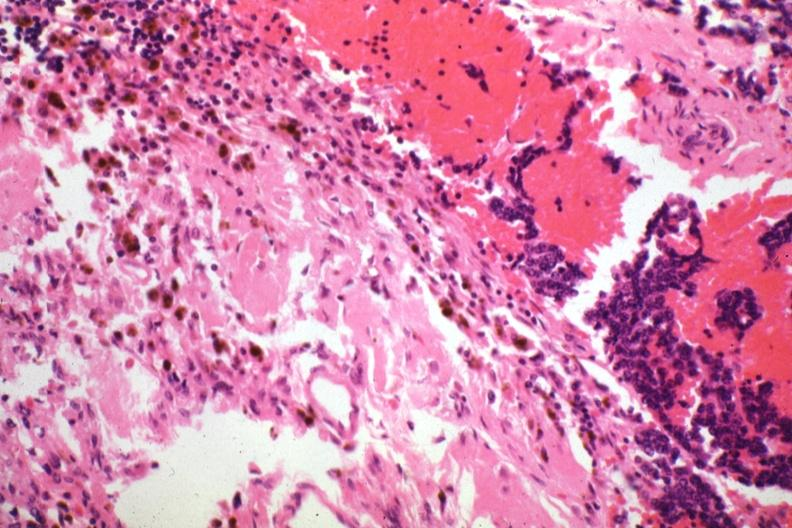what is present?
Answer the question using a single word or phrase. Endocrine 